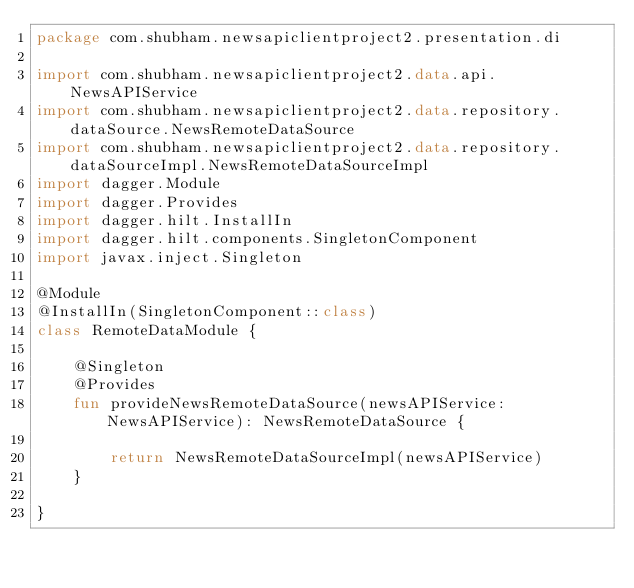Convert code to text. <code><loc_0><loc_0><loc_500><loc_500><_Kotlin_>package com.shubham.newsapiclientproject2.presentation.di

import com.shubham.newsapiclientproject2.data.api.NewsAPIService
import com.shubham.newsapiclientproject2.data.repository.dataSource.NewsRemoteDataSource
import com.shubham.newsapiclientproject2.data.repository.dataSourceImpl.NewsRemoteDataSourceImpl
import dagger.Module
import dagger.Provides
import dagger.hilt.InstallIn
import dagger.hilt.components.SingletonComponent
import javax.inject.Singleton

@Module
@InstallIn(SingletonComponent::class)
class RemoteDataModule {

    @Singleton
    @Provides
    fun provideNewsRemoteDataSource(newsAPIService: NewsAPIService): NewsRemoteDataSource {

        return NewsRemoteDataSourceImpl(newsAPIService)
    }

}</code> 